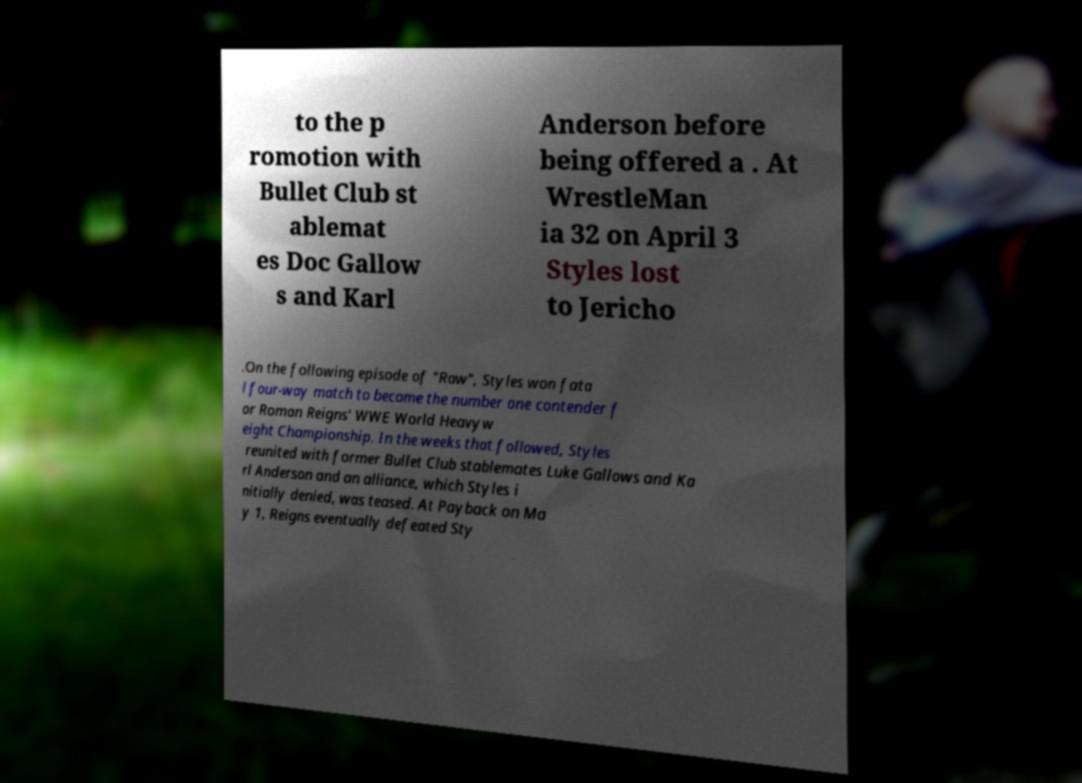There's text embedded in this image that I need extracted. Can you transcribe it verbatim? to the p romotion with Bullet Club st ablemat es Doc Gallow s and Karl Anderson before being offered a . At WrestleMan ia 32 on April 3 Styles lost to Jericho .On the following episode of "Raw", Styles won fata l four-way match to become the number one contender f or Roman Reigns' WWE World Heavyw eight Championship. In the weeks that followed, Styles reunited with former Bullet Club stablemates Luke Gallows and Ka rl Anderson and an alliance, which Styles i nitially denied, was teased. At Payback on Ma y 1, Reigns eventually defeated Sty 